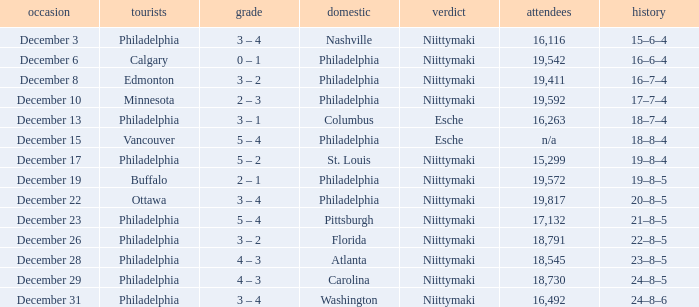What was the score when the attendance was 18,545? 4 – 3. 